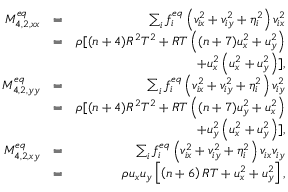Convert formula to latex. <formula><loc_0><loc_0><loc_500><loc_500>\begin{array} { r l r } { M _ { 4 , 2 , x x } ^ { e q } } & { = } & { \sum _ { i } { f _ { i } ^ { e q } \left ( { v _ { i x } ^ { 2 } + v _ { i y } ^ { 2 } + \eta _ { i } ^ { 2 } } \right ) v _ { i x } ^ { 2 } } } \\ & { = } & { \rho [ ( n + 4 ) R ^ { 2 } T ^ { 2 } + R T \left ( ( n + 7 ) u _ { x } ^ { 2 } + u _ { y } ^ { 2 } \right ) } \\ & { + u _ { x } ^ { 2 } \left ( u _ { x } ^ { 2 } + u _ { y } ^ { 2 } \right ) ] , } \\ { M _ { 4 , 2 , y y } ^ { e q } } & { = } & { \sum _ { i } { f _ { i } ^ { e q } \left ( { v _ { i x } ^ { 2 } + v _ { i y } ^ { 2 } + \eta _ { i } ^ { 2 } } \right ) v _ { i y } ^ { 2 } } } \\ & { = } & { \rho [ ( n + 4 ) R ^ { 2 } T ^ { 2 } + R T \left ( ( n + 7 ) u _ { y } ^ { 2 } + u _ { x } ^ { 2 } \right ) } \\ & { + u _ { y } ^ { 2 } \left ( u _ { x } ^ { 2 } + u _ { y } ^ { 2 } \right ) ] , } \\ { M _ { 4 , 2 , x y } ^ { e q } } & { = } & { \sum _ { i } { f _ { i } ^ { e q } \left ( { v _ { i x } ^ { 2 } + v _ { i y } ^ { 2 } + \eta _ { i } ^ { 2 } } \right ) { v _ { i x } } } { v _ { i y } } } \\ & { = } & { \rho { u _ { x } } { u _ { y } } \left [ { \left ( { n + 6 } \right ) R T + u _ { x } ^ { 2 } + u _ { y } ^ { 2 } } \right ] , } \end{array}</formula> 